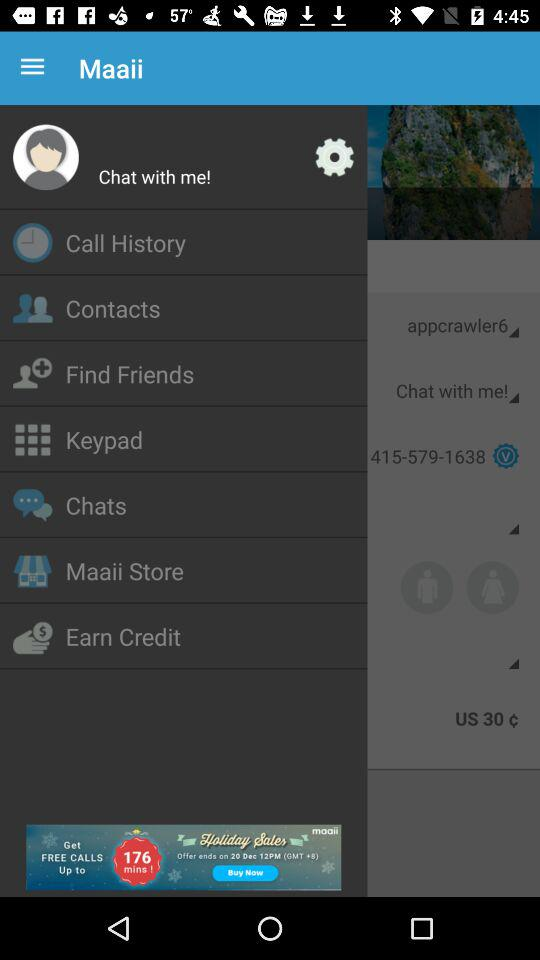What is the contact number? The contact number is 415-579-1638. 